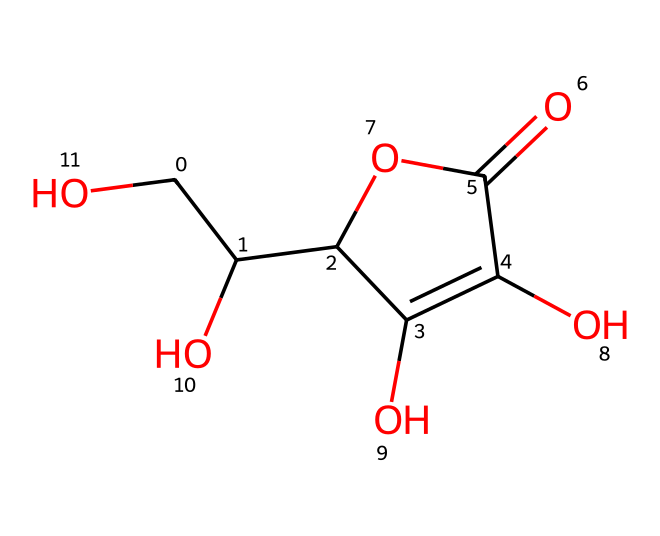How many carbon atoms are in ascorbic acid? By analyzing the given SMILES representation, we can count the number of 'C' symbols, which represent carbon atoms. In this case, there are six carbon atoms present in the structure.
Answer: six What functional groups are present in the structure? The structure contains a carboxylic acid (C(=O)O) and multiple hydroxyl (–OH) groups. The presence of these groups can be identified through the corresponding symbols in the SMILES representation.
Answer: carboxylic acid and hydroxyl groups How many oxygen atoms are in ascorbic acid? We can identify all the 'O' symbols in the SMILES representation. There are two distinct oxygen atoms in the carboxylic acid part, along with additional hydroxyl groups. In total, there are four oxygen atoms.
Answer: four What is the molecular formula for ascorbic acid? By combining the counts of each type of atom (carbon, hydrogen, and oxygen), we derive the molecular formula. There are six carbons, eight hydrogens, and four oxygens, leading to the formula C6H8O4.
Answer: C6H8O4 Is ascorbic acid an acid or a base? Ascorbic acid is classified as an acid due to the presence of the carboxylic acid functional group in its structure, which can donate protons in a solution.
Answer: acid How many hydroxyl (–OH) groups are there? In the chemical structure, each –OH group corresponds to a specific attachment on the carbon skeleton. Upon inspection of the SMILES representation, we find four hydroxyl groups present.
Answer: four What type of isomerism can ascorbic acid exhibit? Ascorbic acid can exhibit geometrical isomerism due to its double bond in the structure. This allows for the possibility of different configurations around the double bond.
Answer: geometrical isomerism 